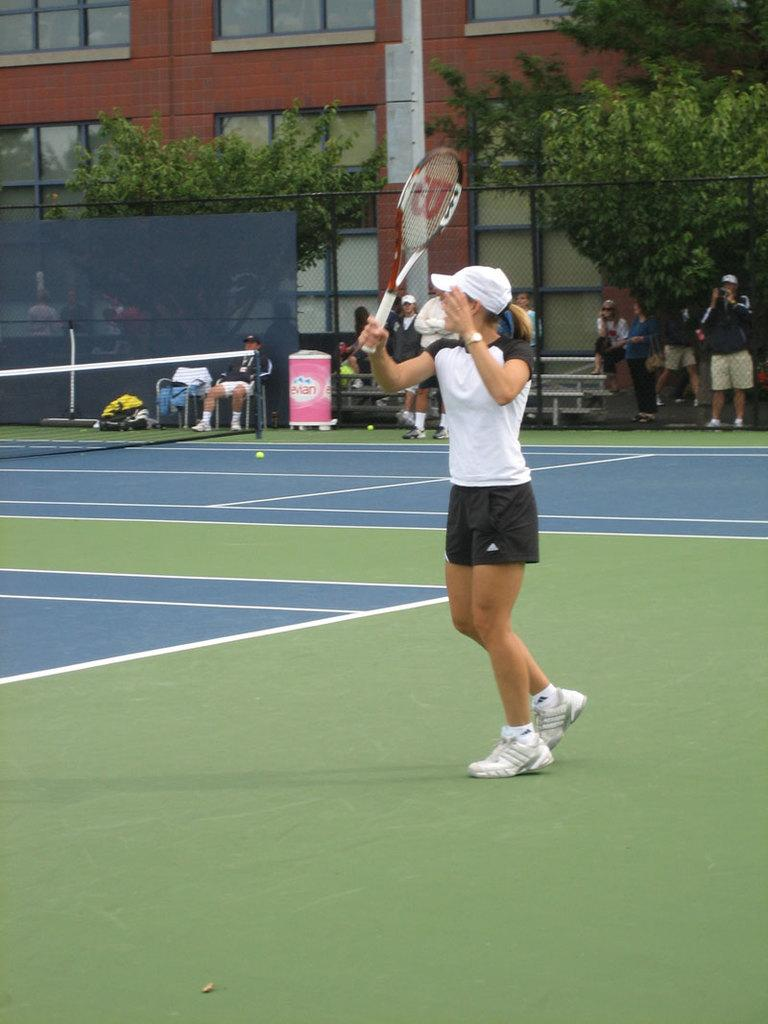Who is present in the image? There is a woman in the image. What is the woman holding in the image? The woman is holding a racket. Where is the woman standing in the image? The woman is standing in a court. What can be seen in the background of the image? There is a net, trees, people, and a building in the background of the image. What type of creature can be seen playing with a quince in the image? There is no creature or quince present in the image. How does the woman create friction with the racket in the image? The image does not show the woman using the racket, so it is not possible to determine how she creates friction with it. 